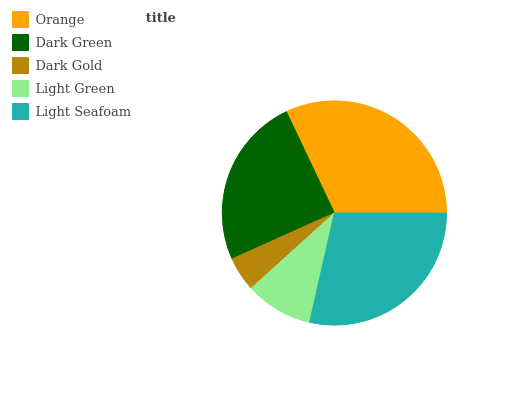Is Dark Gold the minimum?
Answer yes or no. Yes. Is Orange the maximum?
Answer yes or no. Yes. Is Dark Green the minimum?
Answer yes or no. No. Is Dark Green the maximum?
Answer yes or no. No. Is Orange greater than Dark Green?
Answer yes or no. Yes. Is Dark Green less than Orange?
Answer yes or no. Yes. Is Dark Green greater than Orange?
Answer yes or no. No. Is Orange less than Dark Green?
Answer yes or no. No. Is Dark Green the high median?
Answer yes or no. Yes. Is Dark Green the low median?
Answer yes or no. Yes. Is Light Seafoam the high median?
Answer yes or no. No. Is Light Seafoam the low median?
Answer yes or no. No. 